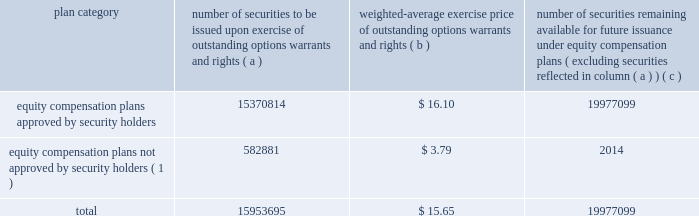Part iii item 10 .
Directors , and executive officers and corporate governance .
Pursuant to section 406 of the sarbanes-oxley act of 2002 , we have adopted a code of ethics for senior financial officers that applies to our principal executive officer and principal financial officer , principal accounting officer and controller , and other persons performing similar functions .
Our code of ethics for senior financial officers is publicly available on our website at www.hologic.com .
We intend to satisfy the disclosure requirement under item 5.05 of current report on form 8-k regarding an amendment to , or waiver from , a provision of this code by posting such information on our website , at the address specified above .
The additional information required by this item is incorporated by reference to our definitive proxy statement for our annual meeting of stockholders to be filed with the securities and exchange commission within 120 days after the close of our fiscal year .
Item 11 .
Executive compensation .
The information required by this item is incorporated by reference to our definitive proxy statement for our annual meeting of stockholders to be filed with the securities and exchange commission within 120 days after the close of our fiscal year .
Item 12 .
Security ownership of certain beneficial owners and management and related stockholder matters .
We maintain a number of equity compensation plans for employees , officers , directors and others whose efforts contribute to our success .
The table below sets forth certain information as of the end of our fiscal year ended september 27 , 2008 regarding the shares of our common stock available for grant or granted under stock option plans and equity incentives that ( i ) were approved by our stockholders , and ( ii ) were not approved by our stockholders .
The number of securities and the exercise price of the outstanding securities have been adjusted to reflect our two-for-one stock splits effected on november 30 , 2005 and april 2 , 2008 .
Equity compensation plan information plan category number of securities to be issued upon exercise of outstanding options , warrants and rights weighted-average exercise price of outstanding options , warrants and rights number of securities remaining available for future issuance under equity compensation plans ( excluding securities reflected in column ( a ) ) equity compensation plans approved by security holders .
15370814 $ 16.10 19977099 equity compensation plans not approved by security holders ( 1 ) .
582881 $ 3.79 2014 .
( 1 ) includes the following plans : 1997 employee equity incentive plan and 2000 acquisition equity incentive plan .
A description of each of these plans is as follows : 1997 employee equity incentive plan .
The purposes of the 1997 employee equity incentive plan ( the 201c1997 plan 201d ) , adopted by the board of directors in may 1997 , are to attract and retain key employees , consultants and advisors , to provide an incentive for them to assist us in achieving long-range performance goals , and to enable such person to participate in our long-term growth .
In general , under the 1997 plan , all employees .
What is the total fair value of options , warrants and rights that are issued and approved by by security holders , ( in millions ) ? 
Computations: ((15370814 * 16.10) / 1000000)
Answer: 247.47011. 